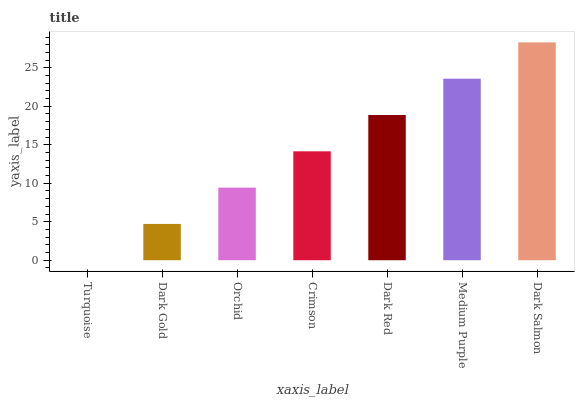Is Turquoise the minimum?
Answer yes or no. Yes. Is Dark Salmon the maximum?
Answer yes or no. Yes. Is Dark Gold the minimum?
Answer yes or no. No. Is Dark Gold the maximum?
Answer yes or no. No. Is Dark Gold greater than Turquoise?
Answer yes or no. Yes. Is Turquoise less than Dark Gold?
Answer yes or no. Yes. Is Turquoise greater than Dark Gold?
Answer yes or no. No. Is Dark Gold less than Turquoise?
Answer yes or no. No. Is Crimson the high median?
Answer yes or no. Yes. Is Crimson the low median?
Answer yes or no. Yes. Is Medium Purple the high median?
Answer yes or no. No. Is Medium Purple the low median?
Answer yes or no. No. 